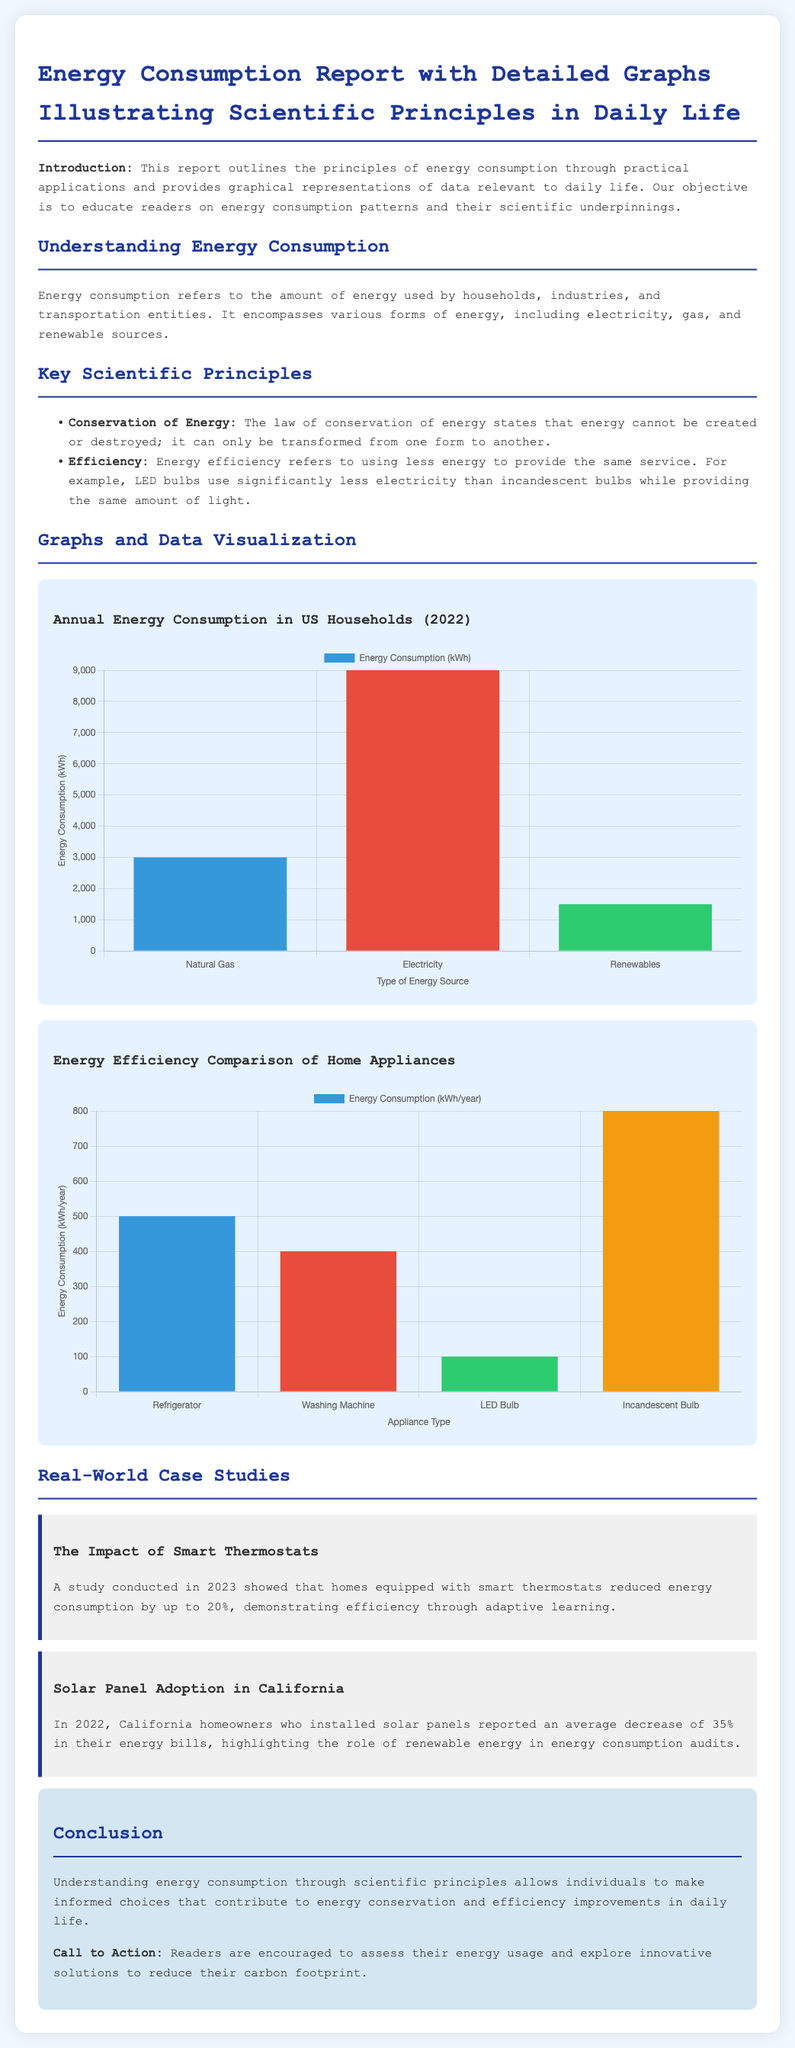What is the title of the report? The title is found at the top of the document, indicating the focus on energy consumption and its scientific principles.
Answer: Energy Consumption Report with Detailed Graphs Illustrating Scientific Principles in Daily Life What year did the study on smart thermostats take place? The year is specified in the case study section discussing smart thermostats.
Answer: 2023 How much did energy consumption reduce by homes with smart thermostats? The percentage reduction is mentioned in the case study which highlights the impact of smart thermostats.
Answer: 20% What type of energy source consumed the most energy in US households? This information is presented in the annual energy consumption chart which lists various energy sources and their usage.
Answer: Electricity What is the average decrease in energy bills for California homeowners with solar panels? This statistic is provided in the case study discussing solar panel adoption in California.
Answer: 35% What is the energy consumption of an LED bulb per year? The energy consumption values are listed in the appliance efficiency comparison chart.
Answer: 100 What fundamental principle does the law of conservation of energy represent? This principle is defined in the key scientific principles section of the document.
Answer: Transformation Which appliance uses the most energy according to the report? The report provides a comparison of appliances and their energy consumption.
Answer: Incandescent Bulb 